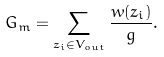<formula> <loc_0><loc_0><loc_500><loc_500>G _ { m } = \sum _ { z _ { i } \in V _ { o u t } } \frac { w ( z _ { i } ) } { g } .</formula> 